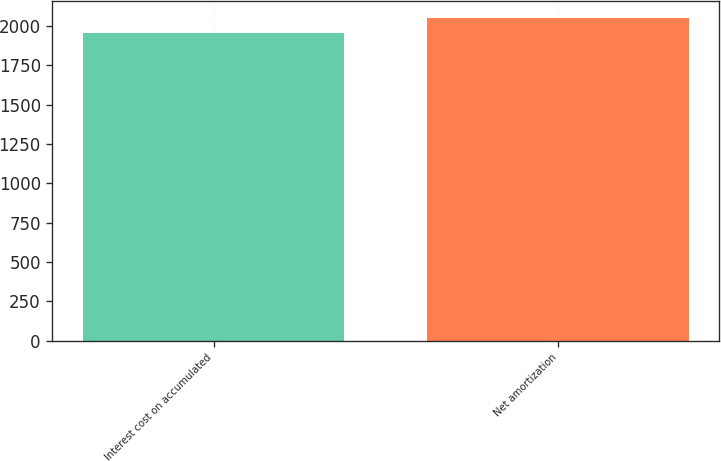Convert chart to OTSL. <chart><loc_0><loc_0><loc_500><loc_500><bar_chart><fcel>Interest cost on accumulated<fcel>Net amortization<nl><fcel>1953<fcel>2054<nl></chart> 